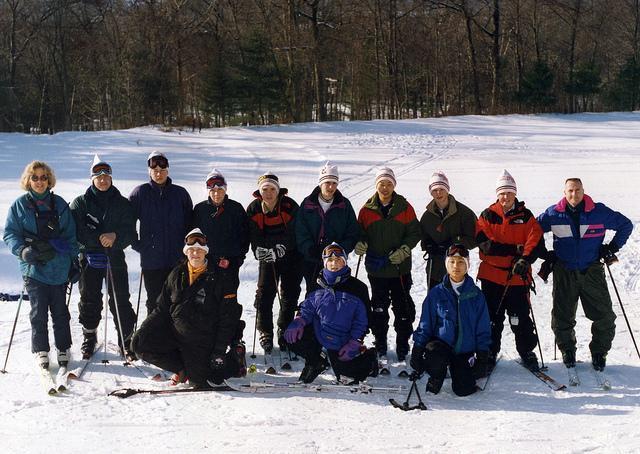How many people are there?
Give a very brief answer. 13. 